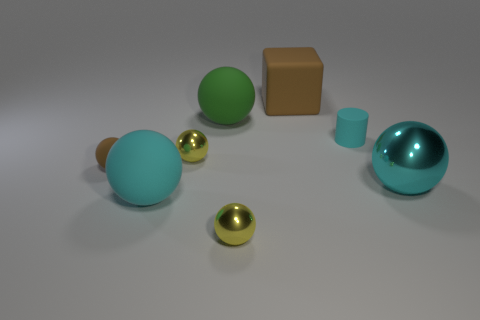Subtract all yellow balls. How many were subtracted if there are1yellow balls left? 1 Subtract 2 balls. How many balls are left? 4 Subtract all cyan spheres. How many spheres are left? 4 Subtract all green spheres. How many spheres are left? 5 Subtract all blue spheres. Subtract all purple cubes. How many spheres are left? 6 Add 2 large purple metallic cylinders. How many objects exist? 10 Subtract all blocks. How many objects are left? 7 Add 1 cylinders. How many cylinders are left? 2 Add 4 cyan cylinders. How many cyan cylinders exist? 5 Subtract 0 yellow cubes. How many objects are left? 8 